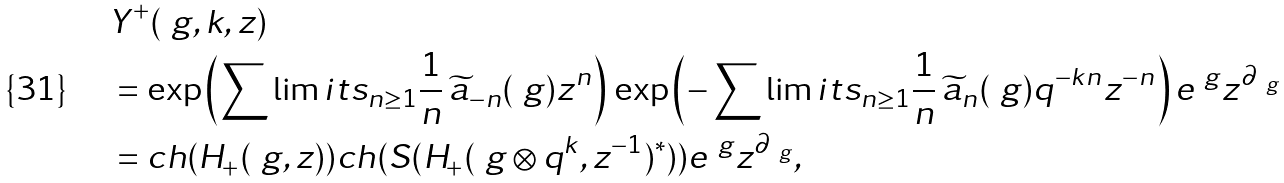<formula> <loc_0><loc_0><loc_500><loc_500>& Y ^ { + } ( \ g , k , z ) \\ & = \exp \left ( \sum \lim i t s _ { n \geq 1 } \frac { 1 } { n } \, \widetilde { a } _ { - n } ( \ g ) z ^ { n } \right ) \, \exp \left ( - \sum \lim i t s _ { n \geq 1 } \frac { 1 } { n } \, { \widetilde { a } _ { n } ( \ g ) } q ^ { - k n } z ^ { - n } \right ) e ^ { \ g } z ^ { \partial _ { \ g } } \\ & = c h ( H _ { + } ( \ g , z ) ) c h ( S ( H _ { + } ( \ g \otimes q ^ { k } , z ^ { - 1 } ) ^ { * } ) ) e ^ { \ g } z ^ { \partial _ { \ g } } ,</formula> 